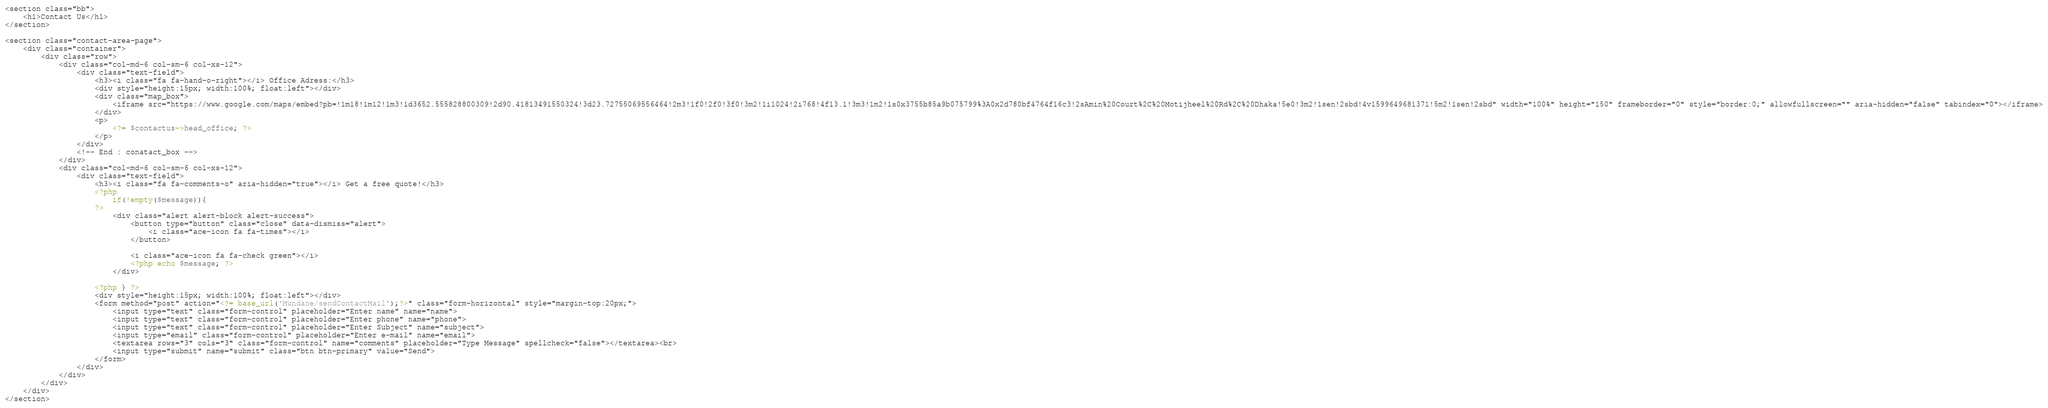<code> <loc_0><loc_0><loc_500><loc_500><_PHP_>
<section class="bb">
    <h1>Contact Us</h1>
</section>

<section class="contact-area-page">
    <div class="container">
        <div class="row">
            <div class="col-md-6 col-sm-6 col-xs-12">
                <div class="text-field">
                    <h3><i class="fa fa-hand-o-right"></i> Office Adress:</h3>
                    <div style="height:15px; width:100%; float:left"></div>
                    <div class="map_box">
                        <iframe src="https://www.google.com/maps/embed?pb=!1m18!1m12!1m3!1d3652.555828800309!2d90.41813491550324!3d23.72755069556464!2m3!1f0!2f0!3f0!3m2!1i1024!2i768!4f13.1!3m3!1m2!1s0x3755b85a9b075799%3A0x2d780bf4764f16c3!2sAmin%20Court%2C%20Motijheel%20Rd%2C%20Dhaka!5e0!3m2!1sen!2sbd!4v1599649681371!5m2!1sen!2sbd" width="100%" height="150" frameborder="0" style="border:0;" allowfullscreen="" aria-hidden="false" tabindex="0"></iframe>
                    </div>
                    <p>
                        <?= $contactus->head_office; ?>
                    </p>
                </div>
                <!-- End : conatact_box -->
            </div>
            <div class="col-md-6 col-sm-6 col-xs-12">
                <div class="text-field">
                    <h3><i class="fa fa-comments-o" aria-hidden="true"></i> Get a free quote!</h3>
                    <?php 
                        if(!empty($message)){
                    ?>
                        <div class="alert alert-block alert-success">
                            <button type="button" class="close" data-dismiss="alert">
                                <i class="ace-icon fa fa-times"></i>
                            </button>

                            <i class="ace-icon fa fa-check green"></i>
                            <?php echo $message; ?>
                        </div>

                    <?php } ?>
                    <div style="height:15px; width:100%; float:left"></div>
                    <form method="post" action="<?= base_url('Mundane/sendContactMail');?>" class="form-horizontal" style="margin-top:20px;">
                        <input type="text" class="form-control" placeholder="Enter name" name="name">
                        <input type="text" class="form-control" placeholder="Enter phone" name="phone">
                        <input type="text" class="form-control" placeholder="Enter Subject" name="subject">
                        <input type="email" class="form-control" placeholder="Enter e-mail" name="email">
                        <textarea rows="3" cols="3" class="form-control" name="comments" placeholder="Type Message" spellcheck="false"></textarea><br>
                        <input type="submit" name="submit" class="btn btn-primary" value="Send">
                    </form>
                </div>
            </div>
        </div>
    </div>
</section></code> 